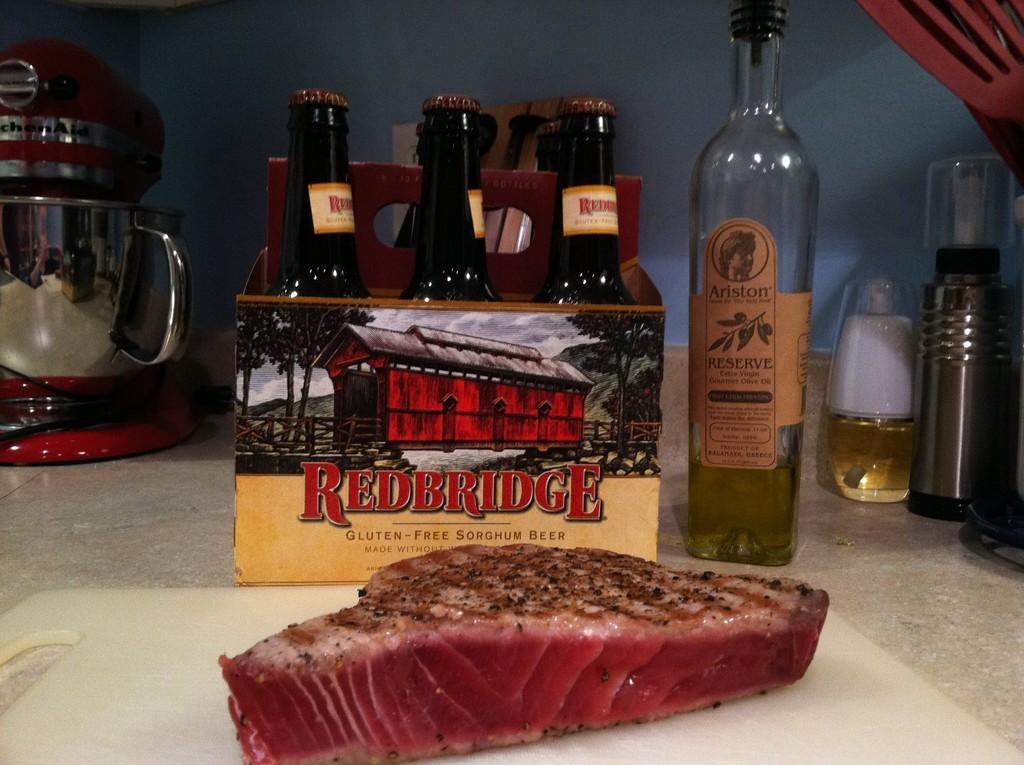<image>
Describe the image concisely. A six pack of beer is labeled gluten free sorghum beer. 